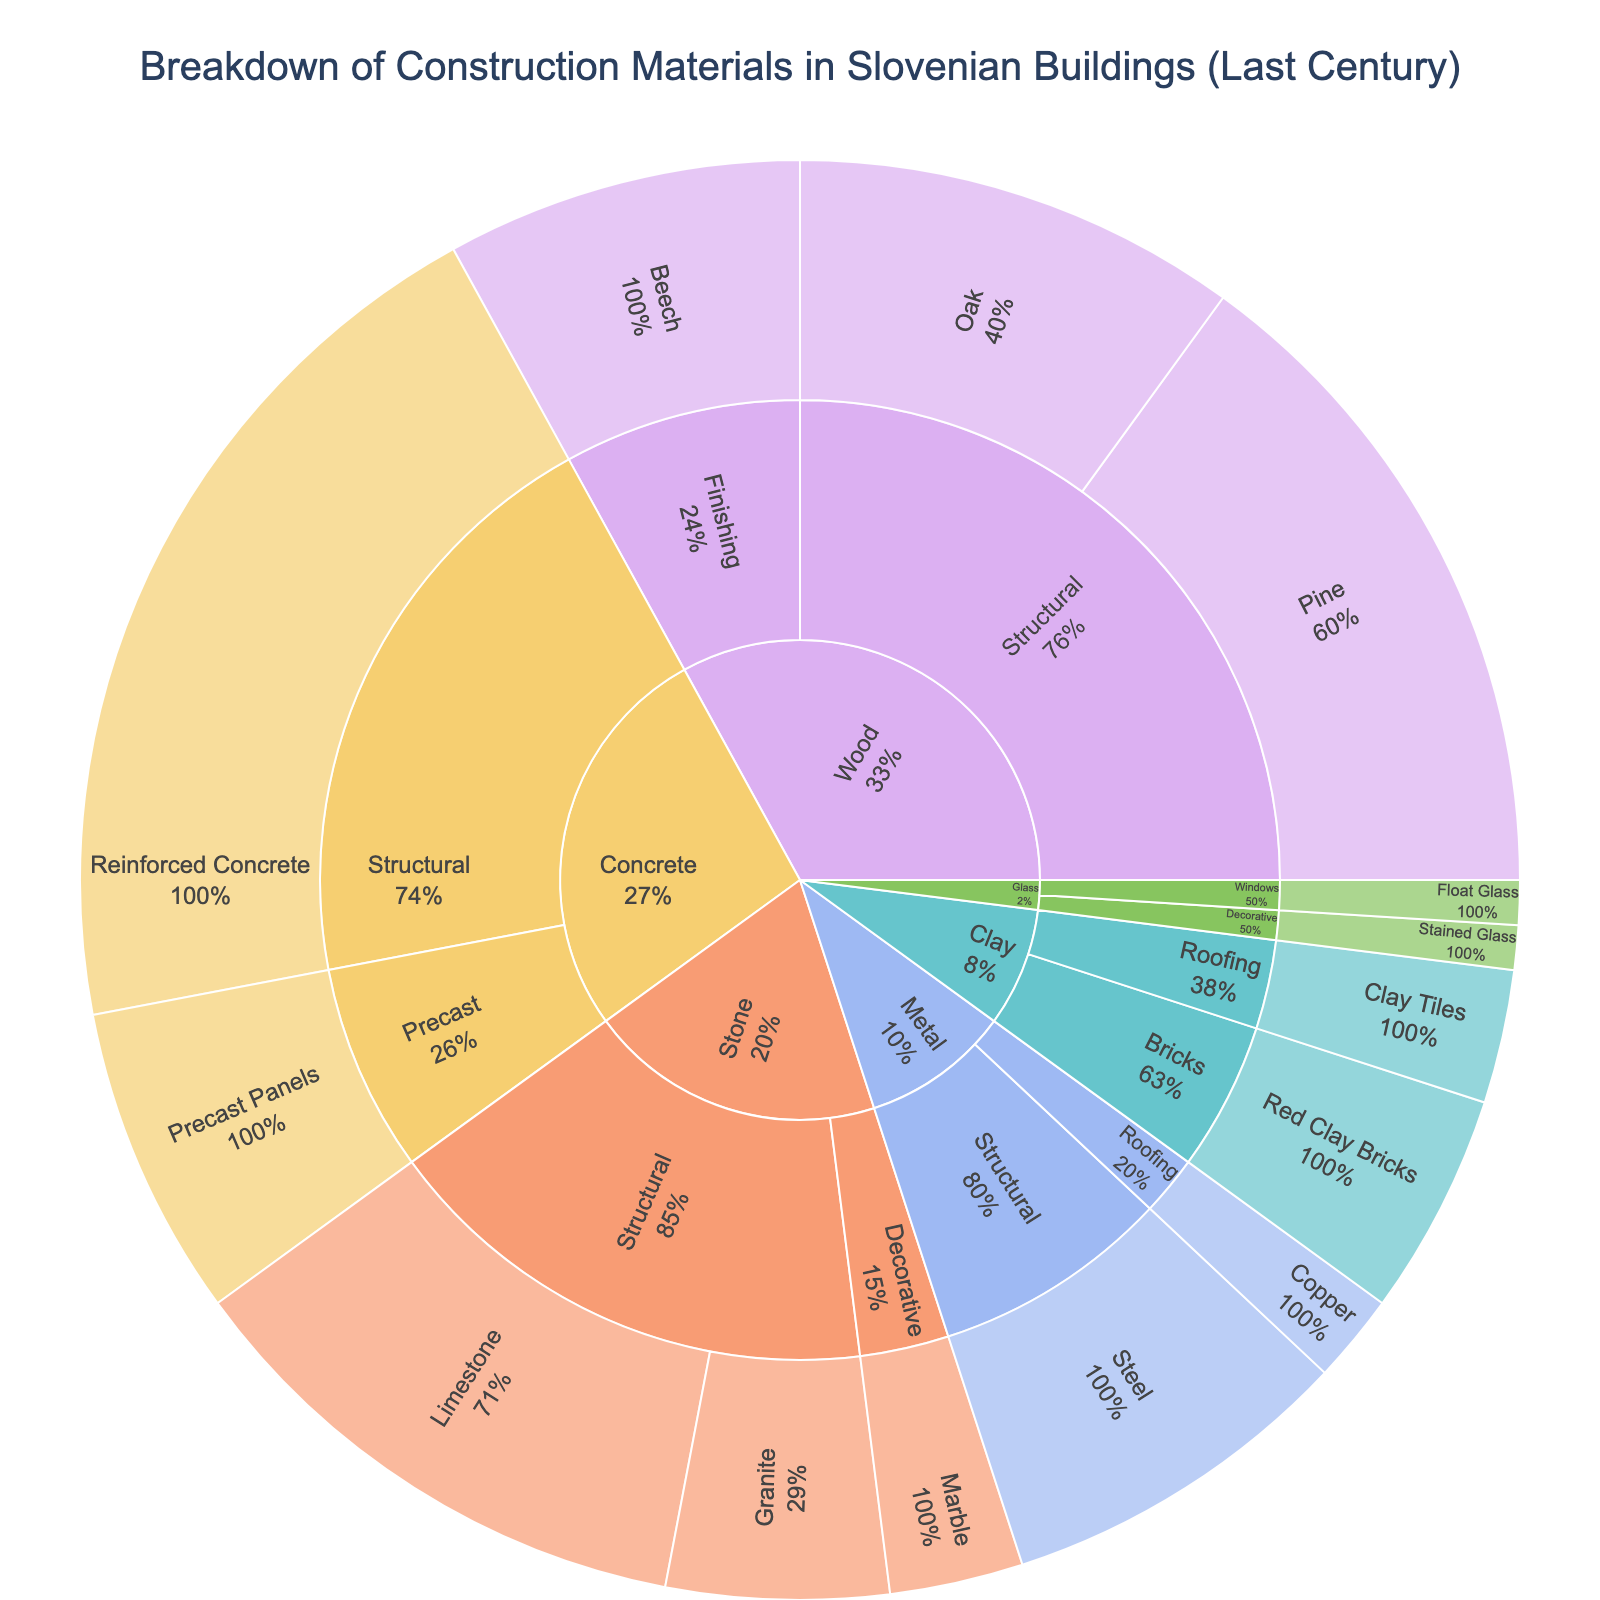What is the title of the sunburst plot? The title is typically found at the top of the plot. It is written clearly and usually large to catch the viewer's attention
Answer: Breakdown of Construction Materials in Slovenian Buildings (Last Century) Which category has the highest percentage of materials used? The size of each category's section in the sunburst plot represents its percentage. The largest section corresponds to the highest percentage.
Answer: Concrete What are the two subcategories under "Wood"? Look at the hierarchical structure of the sunburst plot under the "Wood" section. It branches into two subcategories.
Answer: Structural, Finishing What is the total percentage of structural materials used in Slovenian buildings? Sum the percentages of all materials under the "Structural" subcategory across different categories.
Answer: 20 + 15 + 10 + 12 + 5 + 8 = 70% Which material is used more: Oak (Structural Wood) or Limestone (Structural Stone)? Both materials are part of the structural subcategory, compare their respective percentages.
Answer: Limestone What percentage of materials falls under the category "Metal"? Identify the section for Metal and sum the percentages of its subcategories.
Answer: 8 + 2 = 10% Which has a higher percentage: Precast Concrete panels or Red Clay Bricks? Precast Concrete panels and Red Clay Bricks fall under different categories, compare their individual percentages.
Answer: Precast Concrete panels What percentage of the materials used is categorized under "Glass"? Identify the sections for Glass and sum the percentages of both subcategories.
Answer: 1 + 1 = 2% Is there any category with exactly three subcategories? Examine the subcategories under each category in the sunburst plot.
Answer: No Which material has the lowest percentage representation? Look for the smallest section in the innermost ring of the sunburst plot.
Answer: Stained Glass 